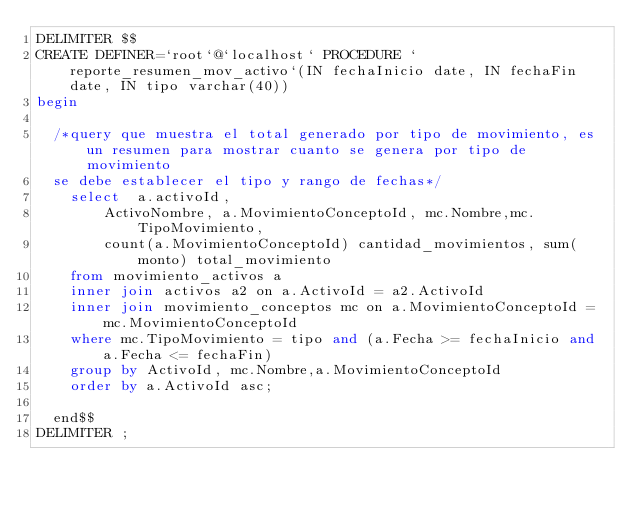<code> <loc_0><loc_0><loc_500><loc_500><_SQL_>DELIMITER $$
CREATE DEFINER=`root`@`localhost` PROCEDURE `reporte_resumen_mov_activo`(IN fechaInicio date, IN fechaFin date, IN tipo varchar(40))
begin 
  
  /*query que muestra el total generado por tipo de movimiento, es un resumen para mostrar cuanto se genera por tipo de movimiento
  se debe establecer el tipo y rango de fechas*/
    select  a.activoId,
        ActivoNombre, a.MovimientoConceptoId, mc.Nombre,mc.TipoMovimiento,
        count(a.MovimientoConceptoId) cantidad_movimientos, sum(monto) total_movimiento
    from movimiento_activos a
    inner join activos a2 on a.ActivoId = a2.ActivoId
    inner join movimiento_conceptos mc on a.MovimientoConceptoId = mc.MovimientoConceptoId
    where mc.TipoMovimiento = tipo and (a.Fecha >= fechaInicio and a.Fecha <= fechaFin)
    group by ActivoId, mc.Nombre,a.MovimientoConceptoId
    order by a.ActivoId asc;  
    
  end$$
DELIMITER ;</code> 